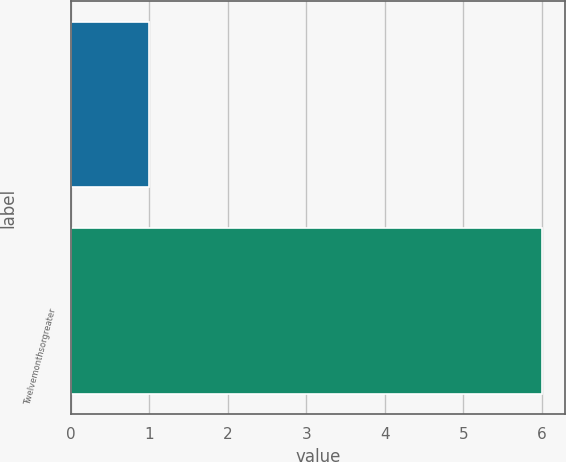Convert chart to OTSL. <chart><loc_0><loc_0><loc_500><loc_500><bar_chart><ecel><fcel>Twelvemonthsorgreater<nl><fcel>1<fcel>6<nl></chart> 